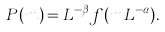<formula> <loc_0><loc_0><loc_500><loc_500>P ( m ) = L ^ { - \beta } f ( m L ^ { - \alpha } ) .</formula> 